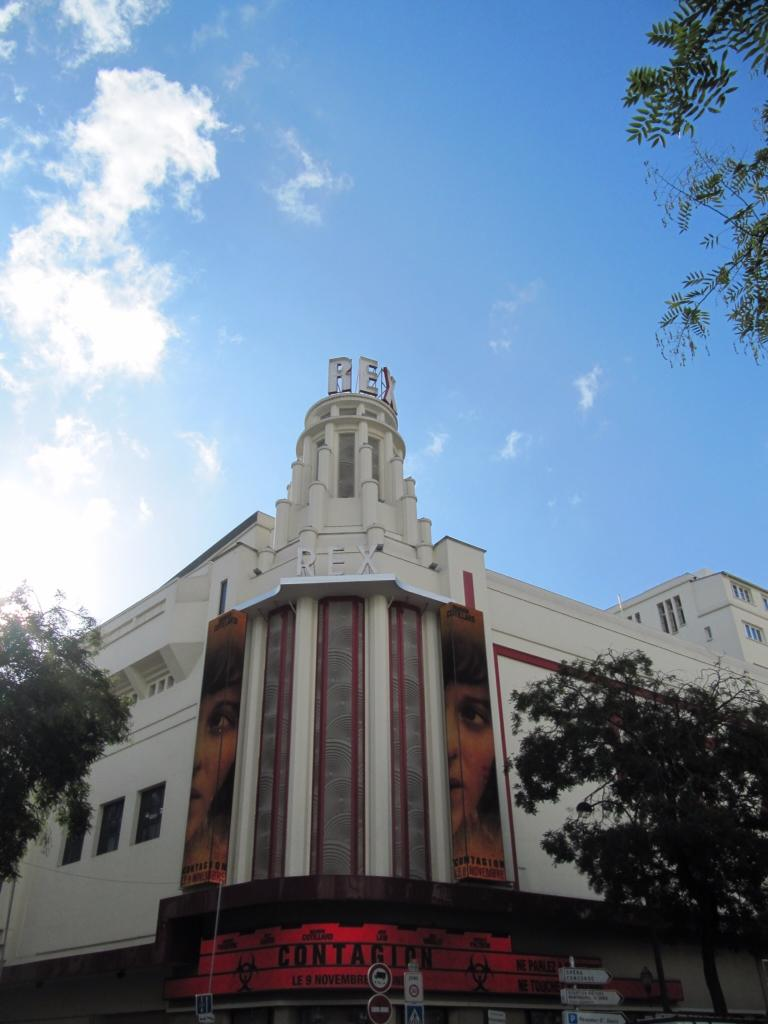<image>
Summarize the visual content of the image. The advertisement for Contagion is in the front of a very tall building 